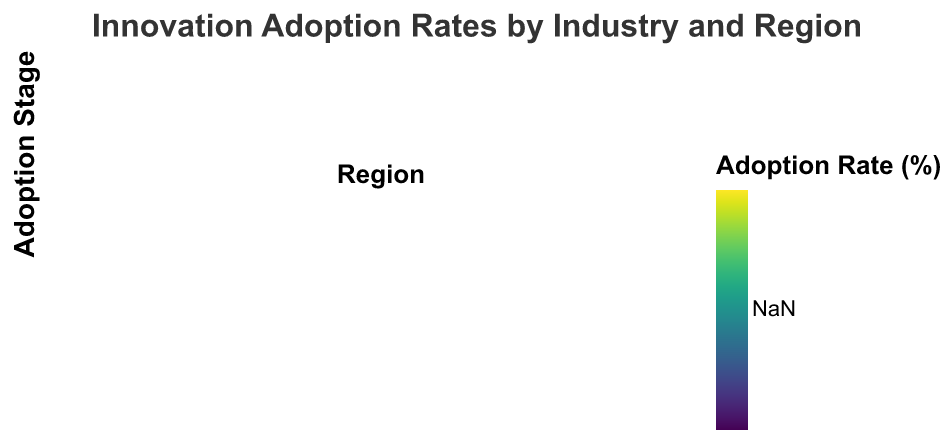What is the highest adoption rate for early adopters across all industries and regions? Traverse through the "Early Adopters" rates for all industries and regions. Identify the highest value. The maximum rate for early adopters is 30% (Technology in Asia).
Answer: 30% Which region has the highest percentage of late majority adopters in the manufacturing industry? Check the data for the late majority adoption rates within the manufacturing industry across different regions. Asia and North America both have a 40% late majority rate, but Europe has 45%, thus being the highest.
Answer: Europe In the healthcare industry, how does the adoption rate of early adopters compare between North America and Europe? Evaluate the early adopters' rates of the healthcare industry in both North America and Europe. North America has 15% and Europe has 10%.
Answer: North America has a higher rate What is the difference in the early majority adoption rate between the technology and healthcare sectors in Europe? Identify the early majority rates for technology (35%) and healthcare (40%) in Europe. Subtract the rate of technology from that of healthcare: 40% - 35% = 5%.
Answer: 5% Which industry in Asia shows the lowest percentage of laggards, and what is that percentage? Inspect the laggards' rates for all industries in Asia. The technology industry has the lowest percentage at 5%.
Answer: Technology, 5% What is the average adoption rate for the early adopters in the finance industry across all regions? Add the early adopters’ rates for finance in all regions (20% + 15% + 25%) and divide by the number of regions (3). The average is (20 + 15 + 25) / 3 = 20%.
Answer: 20% Which region demonstrates the highest average rate for early majority adoption across all industries? Calculate average early majority rates for each region across all industries. North America: (40+35+40+30+35)/5=36%. Europe: (35+40+35+25+40)/5=35%. Asia: (45+30+35+30+35)/5=35%. North America has the highest average.
Answer: North America How does the adoption rate of laggards in the retail industry in North America compare to that in Europe? Identify the laggards' rates for retail in North America (15%) and Europe (15%). Both rates are equal, so there's no difference.
Answer: They are the same Which industry exhibits the greatest variance in early majority adoption rates across different regions? Calculate the range (difference between max and min values) of early majority adoption rates for each industry. Technology: max 45%, min 35%, range 10%. Healthcare: max 40%, min 30%, range 10%. Finance: max 40%, min 35%, range 5%. Manufacturing: max 30%, min 25%, range 5%. Retail: max 40%, min 35%, range 5%. Both Technology and Healthcare have the highest variance (10%).
Answer: Technology and Healthcare have the same highest variance What is the combined percentage of late majority and laggards in North America's manufacturing industry? Add the late majority rate (40%) and laggards rate (20%) for the manufacturing industry in North America. 40% + 20% = 60%.
Answer: 60% 